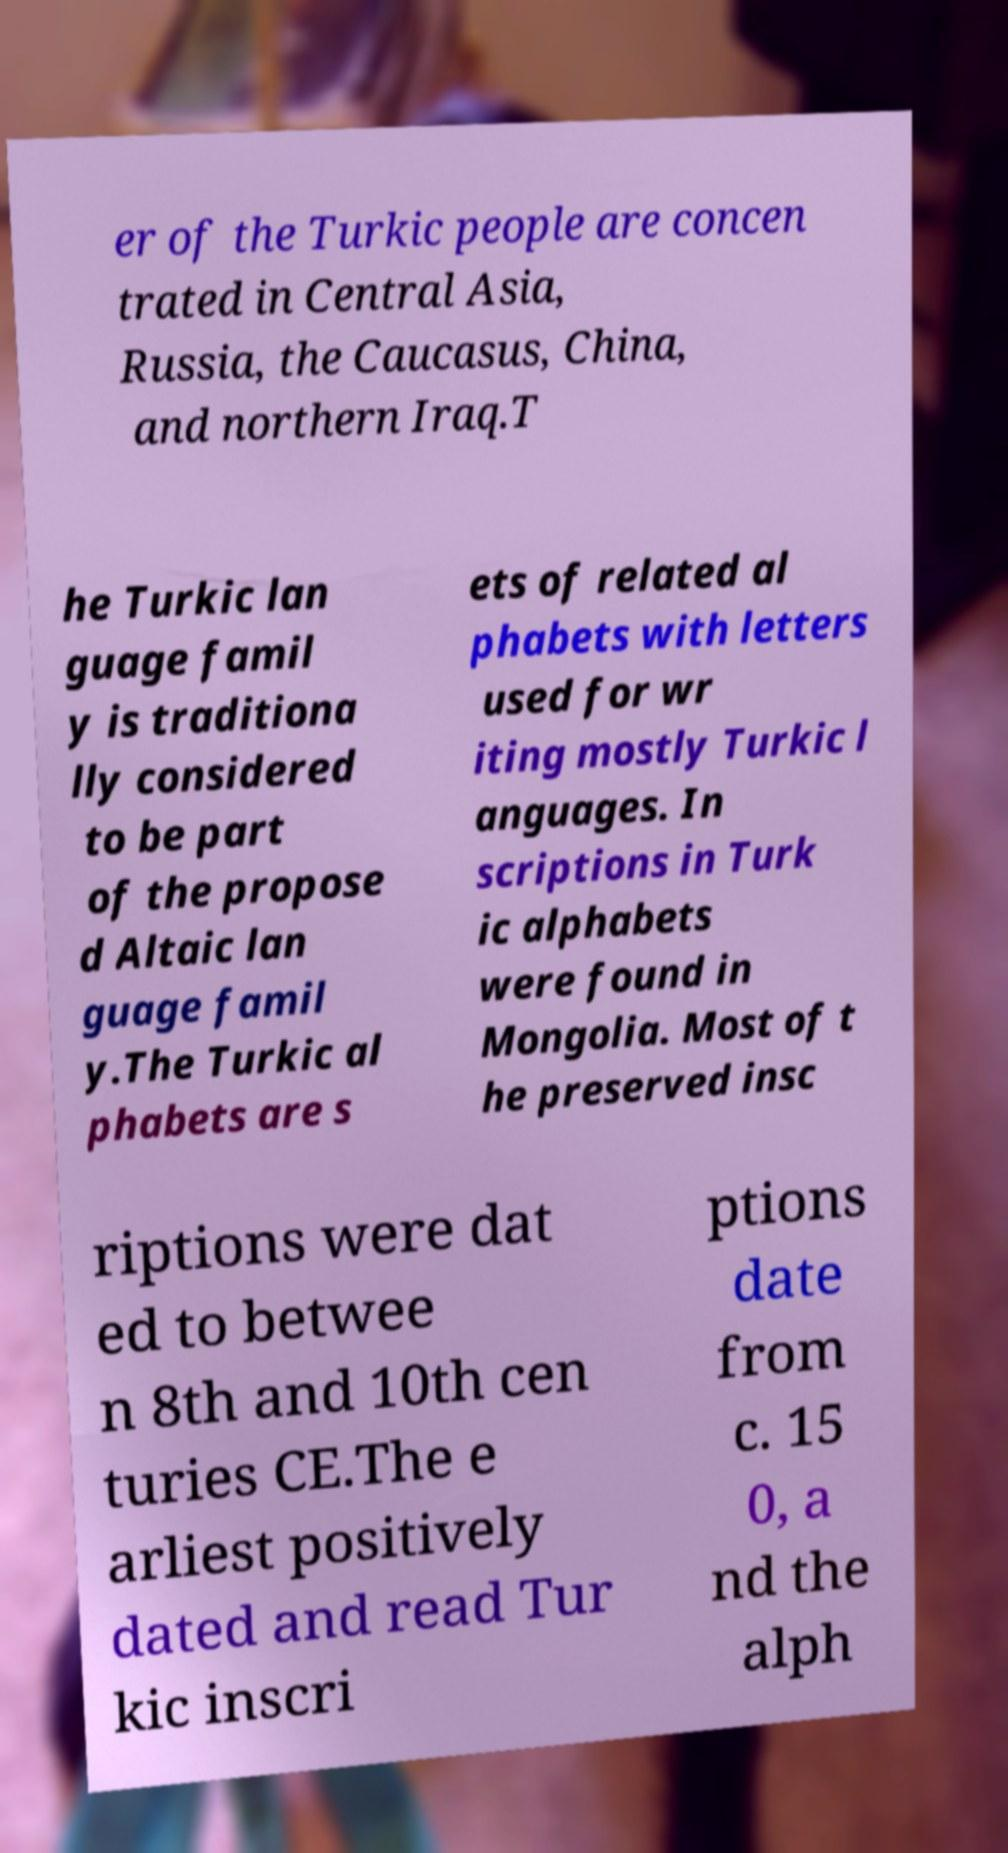Please identify and transcribe the text found in this image. er of the Turkic people are concen trated in Central Asia, Russia, the Caucasus, China, and northern Iraq.T he Turkic lan guage famil y is traditiona lly considered to be part of the propose d Altaic lan guage famil y.The Turkic al phabets are s ets of related al phabets with letters used for wr iting mostly Turkic l anguages. In scriptions in Turk ic alphabets were found in Mongolia. Most of t he preserved insc riptions were dat ed to betwee n 8th and 10th cen turies CE.The e arliest positively dated and read Tur kic inscri ptions date from c. 15 0, a nd the alph 